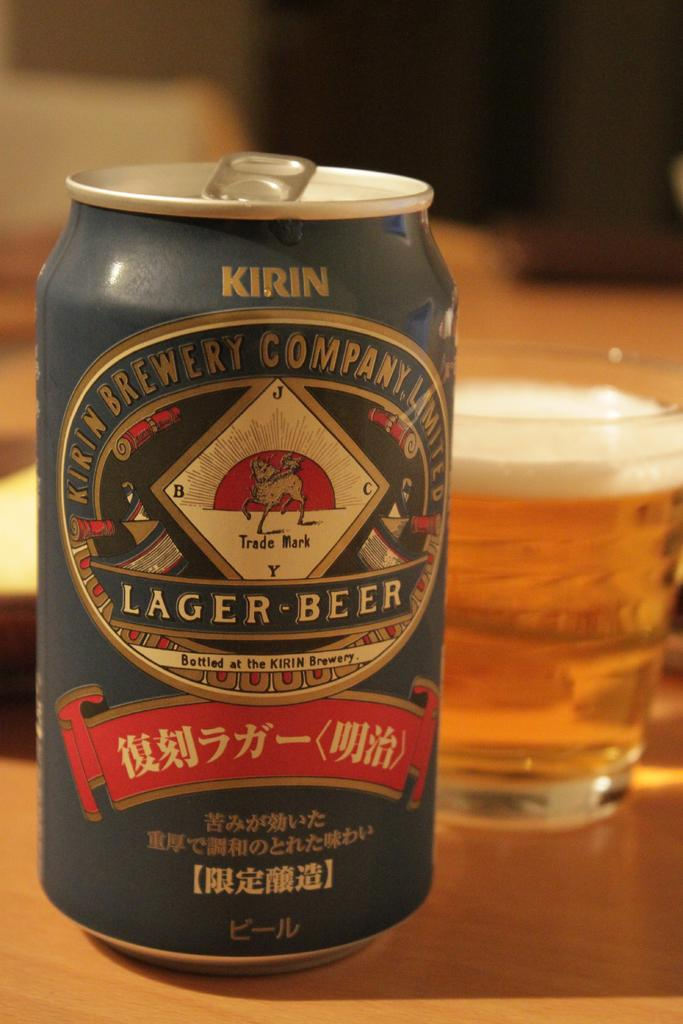<image>
Describe the image concisely. A blue bottle has Kirin at the top and lager beer in the center of the label. 